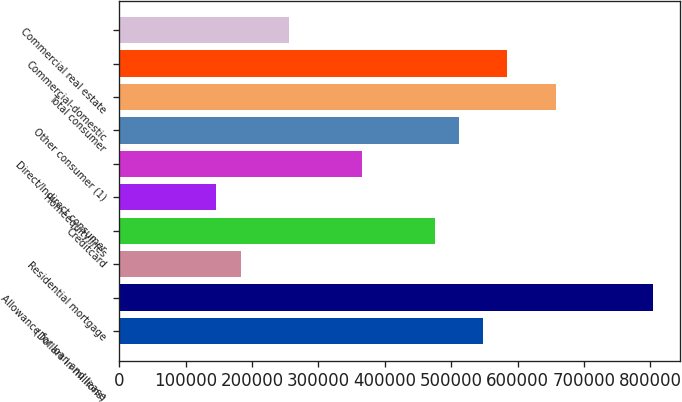Convert chart. <chart><loc_0><loc_0><loc_500><loc_500><bar_chart><fcel>(Dollars in millions)<fcel>Allowance for loan and lease<fcel>Residential mortgage<fcel>Creditcard<fcel>Homeequitylines<fcel>Direct/Indirect consumer<fcel>Other consumer (1)<fcel>Total consumer<fcel>Commercial-domestic<fcel>Commercial real estate<nl><fcel>548170<fcel>803982<fcel>182724<fcel>475081<fcel>146179<fcel>365447<fcel>511625<fcel>657804<fcel>584715<fcel>255813<nl></chart> 